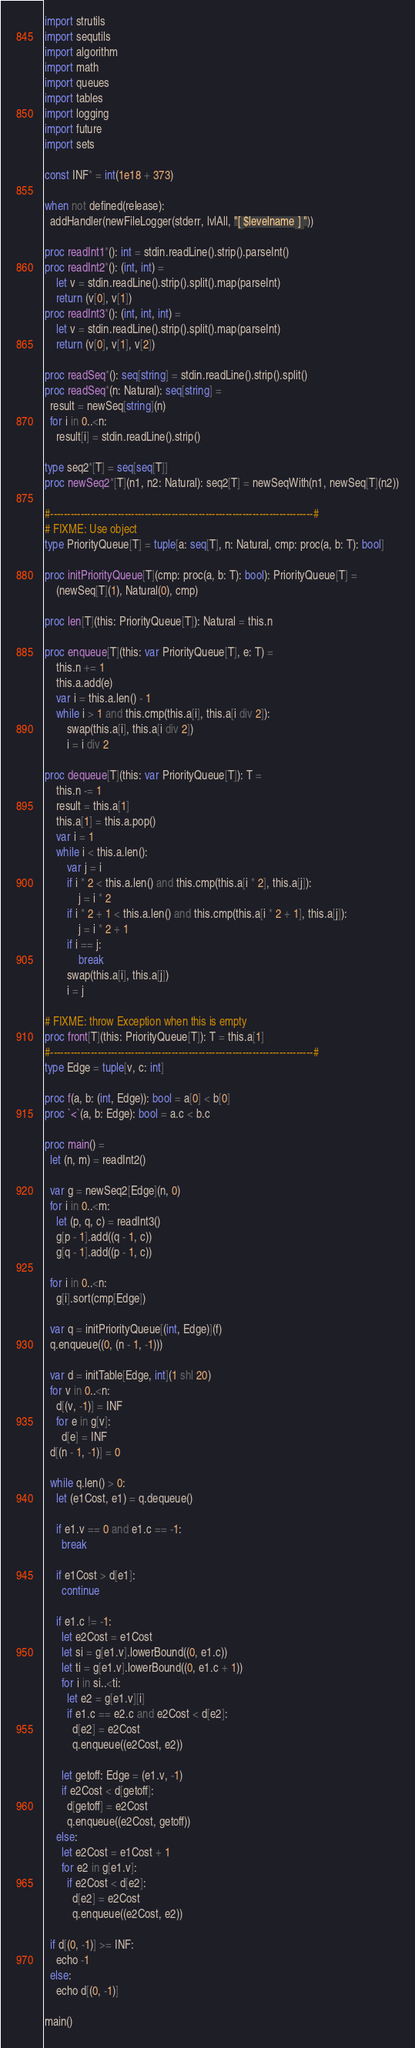Convert code to text. <code><loc_0><loc_0><loc_500><loc_500><_Nim_>import strutils
import sequtils
import algorithm
import math
import queues
import tables
import logging
import future
import sets

const INF* = int(1e18 + 373)

when not defined(release):
  addHandler(newFileLogger(stderr, lvlAll, "[ $levelname ] "))

proc readInt1*(): int = stdin.readLine().strip().parseInt()
proc readInt2*(): (int, int) =
    let v = stdin.readLine().strip().split().map(parseInt)
    return (v[0], v[1])
proc readInt3*(): (int, int, int) =
    let v = stdin.readLine().strip().split().map(parseInt)
    return (v[0], v[1], v[2])

proc readSeq*(): seq[string] = stdin.readLine().strip().split()
proc readSeq*(n: Natural): seq[string] =
  result = newSeq[string](n)
  for i in 0..<n:
    result[i] = stdin.readLine().strip()

type seq2*[T] = seq[seq[T]]
proc newSeq2*[T](n1, n2: Natural): seq2[T] = newSeqWith(n1, newSeq[T](n2))

#------------------------------------------------------------------------------#
# FIXME: Use object
type PriorityQueue[T] = tuple[a: seq[T], n: Natural, cmp: proc(a, b: T): bool]

proc initPriorityQueue[T](cmp: proc(a, b: T): bool): PriorityQueue[T] =
    (newSeq[T](1), Natural(0), cmp)

proc len[T](this: PriorityQueue[T]): Natural = this.n

proc enqueue[T](this: var PriorityQueue[T], e: T) =
    this.n += 1
    this.a.add(e)
    var i = this.a.len() - 1
    while i > 1 and this.cmp(this.a[i], this.a[i div 2]):
        swap(this.a[i], this.a[i div 2])
        i = i div 2

proc dequeue[T](this: var PriorityQueue[T]): T =
    this.n -= 1
    result = this.a[1]
    this.a[1] = this.a.pop()
    var i = 1
    while i < this.a.len():
        var j = i
        if i * 2 < this.a.len() and this.cmp(this.a[i * 2], this.a[j]):
            j = i * 2
        if i * 2 + 1 < this.a.len() and this.cmp(this.a[i * 2 + 1], this.a[j]):
            j = i * 2 + 1
        if i == j:
            break
        swap(this.a[i], this.a[j])
        i = j

# FIXME: throw Exception when this is empty
proc front[T](this: PriorityQueue[T]): T = this.a[1]
#------------------------------------------------------------------------------#
type Edge = tuple[v, c: int]

proc f(a, b: (int, Edge)): bool = a[0] < b[0]
proc `<`(a, b: Edge): bool = a.c < b.c

proc main() =
  let (n, m) = readInt2()

  var g = newSeq2[Edge](n, 0)
  for i in 0..<m:
    let (p, q, c) = readInt3()
    g[p - 1].add((q - 1, c))
    g[q - 1].add((p - 1, c))

  for i in 0..<n:
    g[i].sort(cmp[Edge])

  var q = initPriorityQueue[(int, Edge)](f)
  q.enqueue((0, (n - 1, -1)))

  var d = initTable[Edge, int](1 shl 20)
  for v in 0..<n:
    d[(v, -1)] = INF
    for e in g[v]:
      d[e] = INF
  d[(n - 1, -1)] = 0

  while q.len() > 0:
    let (e1Cost, e1) = q.dequeue()

    if e1.v == 0 and e1.c == -1:
      break

    if e1Cost > d[e1]:
      continue

    if e1.c != -1:
      let e2Cost = e1Cost
      let si = g[e1.v].lowerBound((0, e1.c))
      let ti = g[e1.v].lowerBound((0, e1.c + 1))
      for i in si..<ti:
        let e2 = g[e1.v][i]
        if e1.c == e2.c and e2Cost < d[e2]:
          d[e2] = e2Cost
          q.enqueue((e2Cost, e2))

      let getoff: Edge = (e1.v, -1)
      if e2Cost < d[getoff]:
        d[getoff] = e2Cost
        q.enqueue((e2Cost, getoff))
    else:
      let e2Cost = e1Cost + 1
      for e2 in g[e1.v]:
        if e2Cost < d[e2]:
          d[e2] = e2Cost
          q.enqueue((e2Cost, e2))

  if d[(0, -1)] >= INF:
    echo -1
  else:
    echo d[(0, -1)]

main()


</code> 